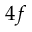<formula> <loc_0><loc_0><loc_500><loc_500>4 f</formula> 